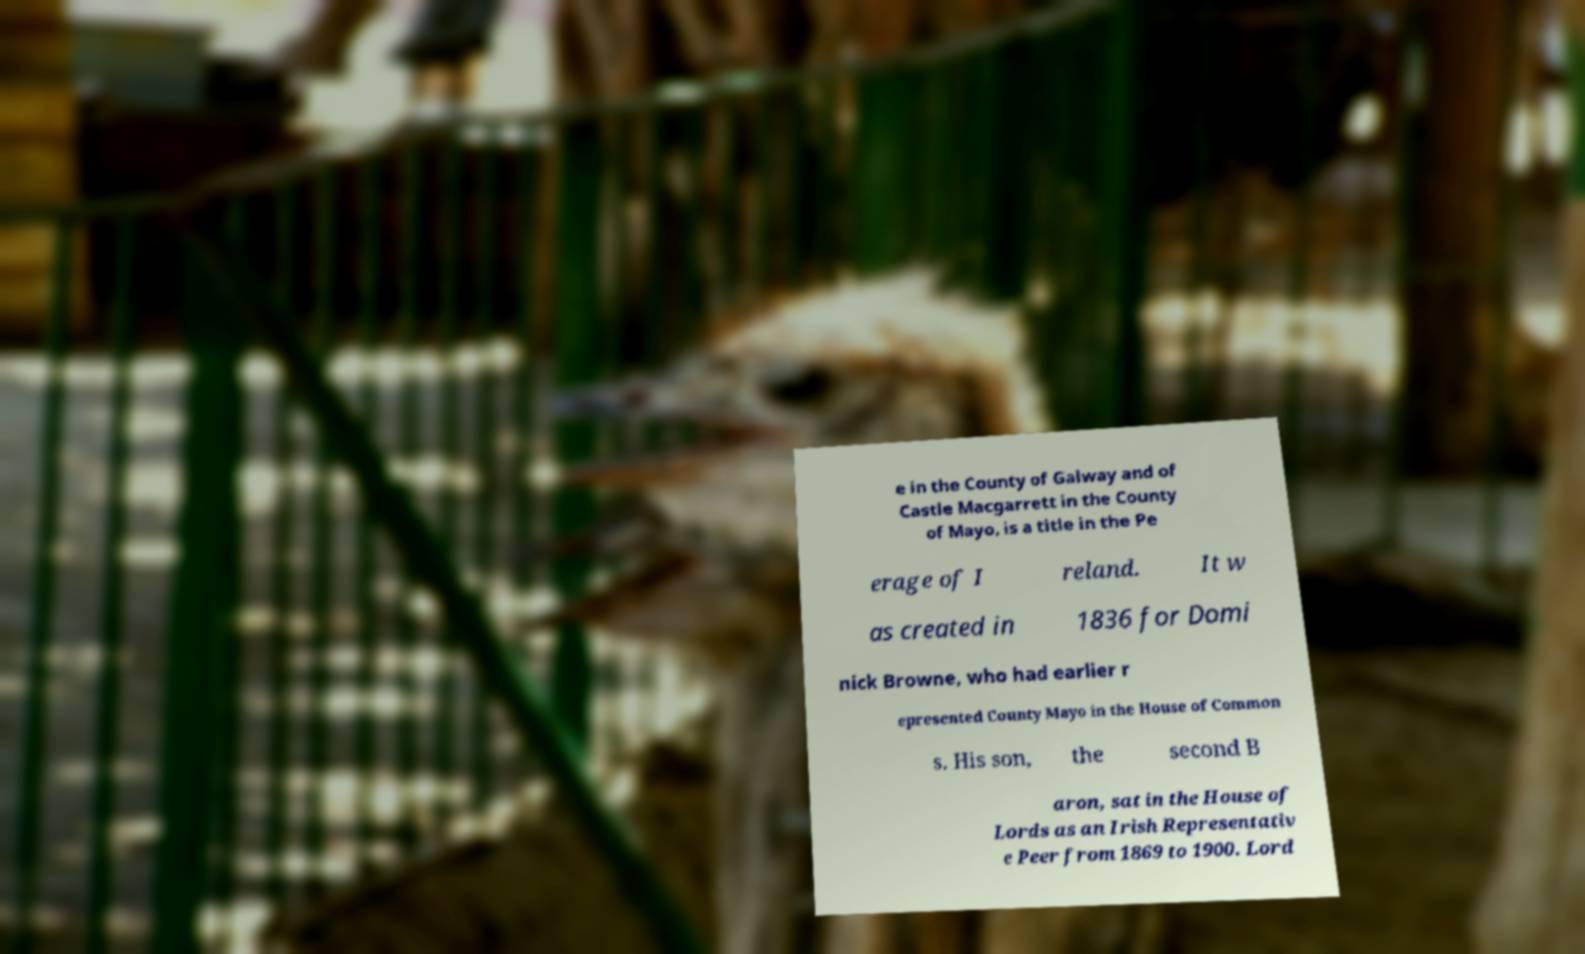For documentation purposes, I need the text within this image transcribed. Could you provide that? e in the County of Galway and of Castle Macgarrett in the County of Mayo, is a title in the Pe erage of I reland. It w as created in 1836 for Domi nick Browne, who had earlier r epresented County Mayo in the House of Common s. His son, the second B aron, sat in the House of Lords as an Irish Representativ e Peer from 1869 to 1900. Lord 